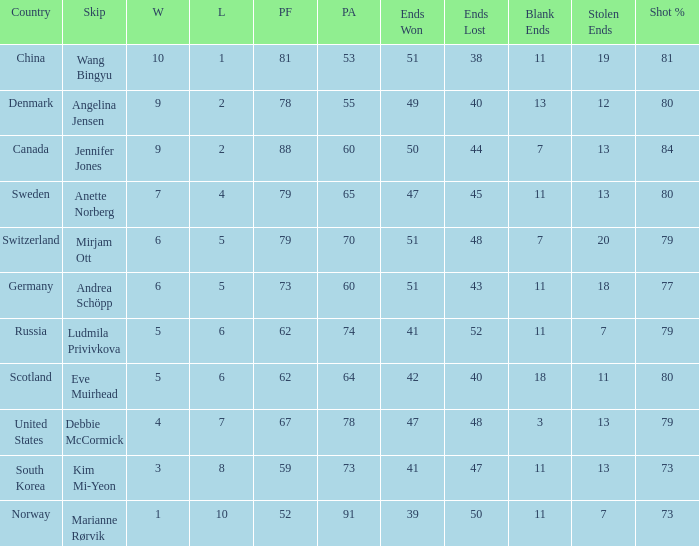In the nation of scotland, how many ends were achieved? 1.0. 